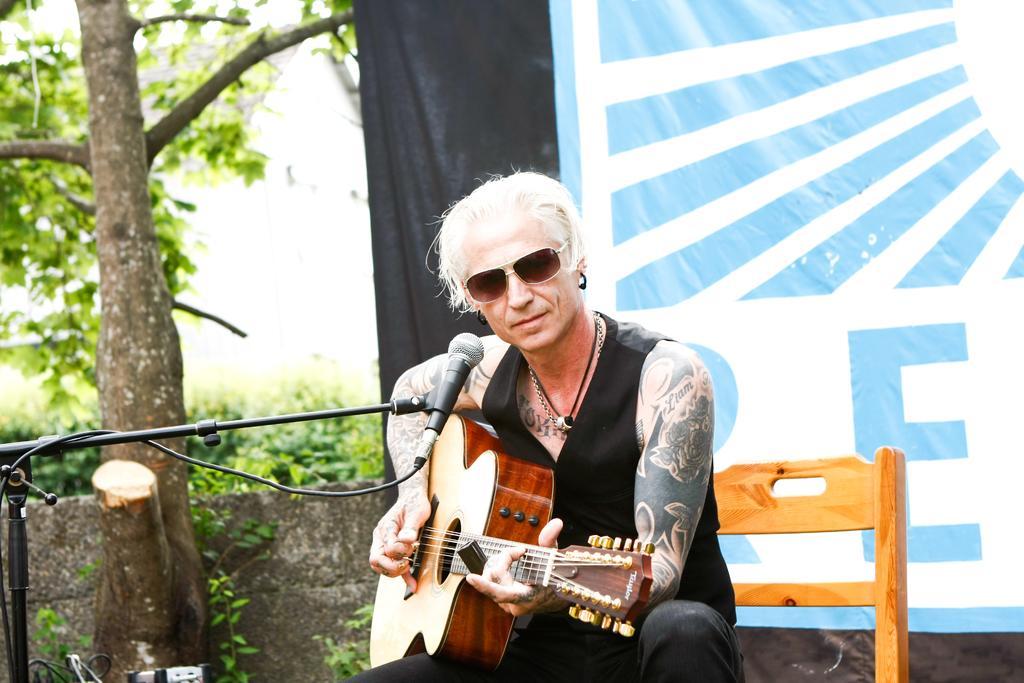Can you describe this image briefly? A man is sitting on the chair and playing guitar. Behind him there is a banner. On the left there is a tree,plants and a mic with stand. 